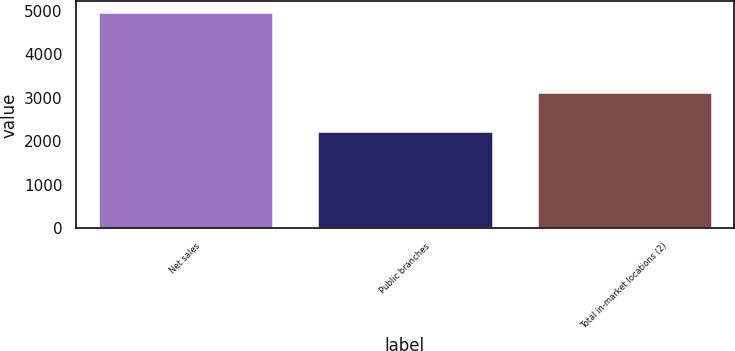<chart> <loc_0><loc_0><loc_500><loc_500><bar_chart><fcel>Net sales<fcel>Public branches<fcel>Total in-market locations (2)<nl><fcel>4965.1<fcel>2227<fcel>3121<nl></chart> 